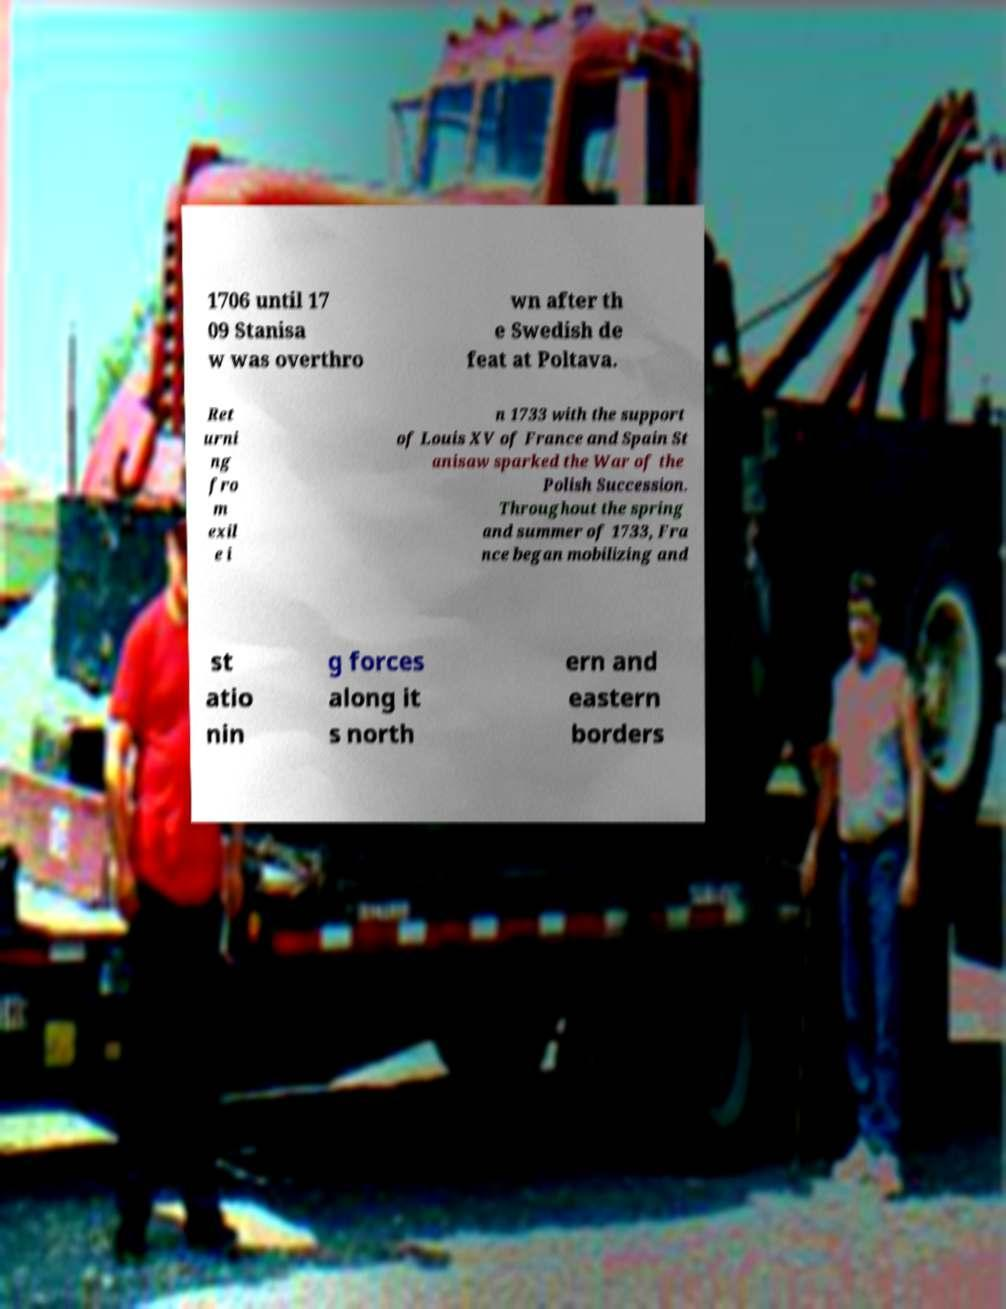Can you accurately transcribe the text from the provided image for me? 1706 until 17 09 Stanisa w was overthro wn after th e Swedish de feat at Poltava. Ret urni ng fro m exil e i n 1733 with the support of Louis XV of France and Spain St anisaw sparked the War of the Polish Succession. Throughout the spring and summer of 1733, Fra nce began mobilizing and st atio nin g forces along it s north ern and eastern borders 